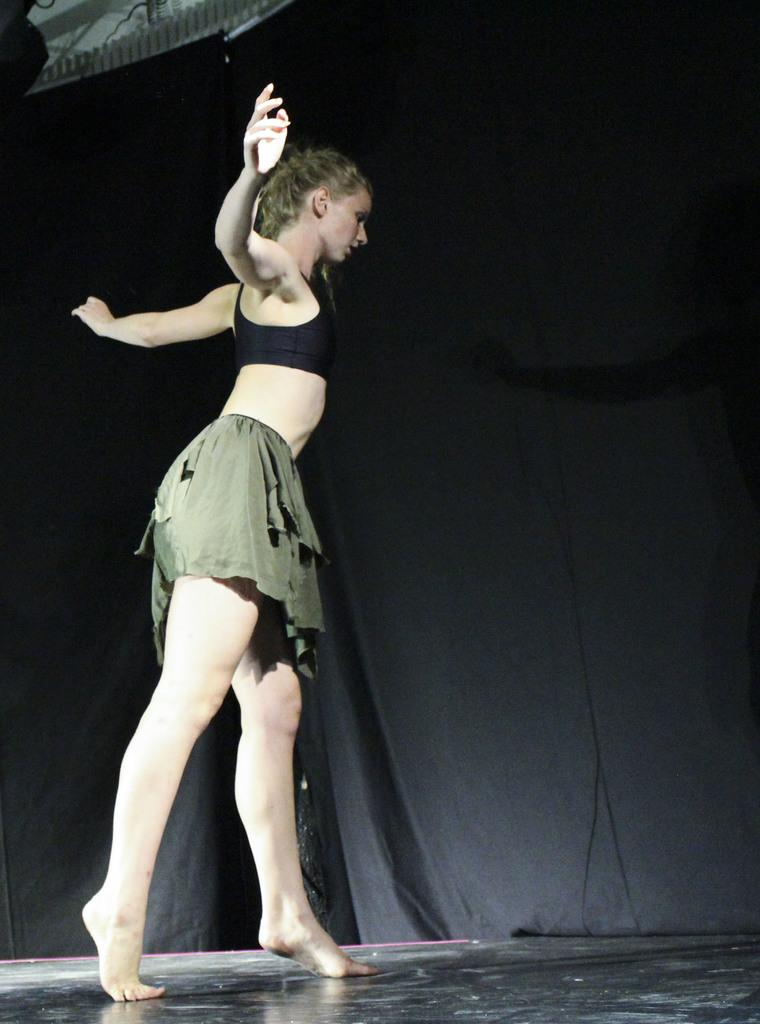Who is the main subject in the image? There is a lady in the image. What is the lady doing in the image? The lady is standing on her toes. What is the surface beneath the lady's feet in the image? There is a floor visible in the image. What can be seen in the background of the image? There is a black color curtain in the background of the image. What time of day is depicted in the image? The time of day cannot be determined from the image, as there are no clues or indicators of time. 